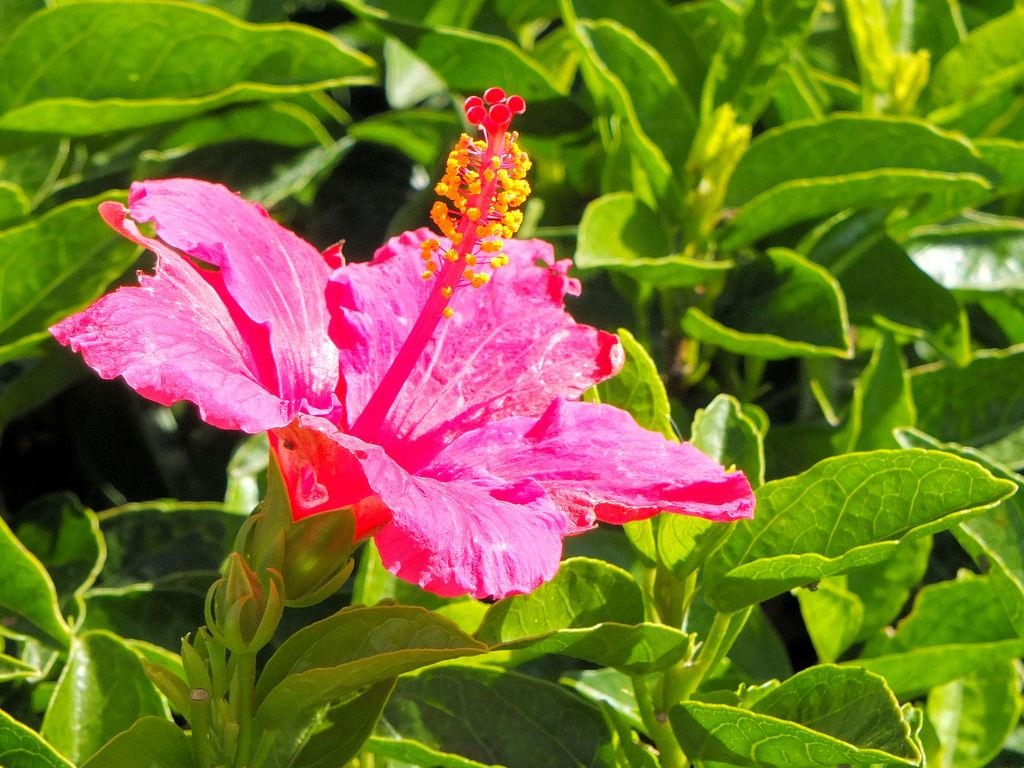What type of flower is in the image? The flower in the image is a hibiscus. What color is the hibiscus flower? The hibiscus flower is pink in color. What other plant elements can be seen in the image? There are leaves in the image. What color are the leaves? The leaves are green in color. What type of noise can be heard coming from the hibiscus flower in the image? There is no noise coming from the hibiscus flower in the image, as flowers do not produce sound. 